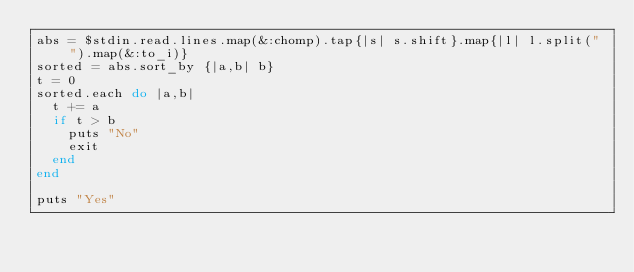<code> <loc_0><loc_0><loc_500><loc_500><_Ruby_>abs = $stdin.read.lines.map(&:chomp).tap{|s| s.shift}.map{|l| l.split(" ").map(&:to_i)}
sorted = abs.sort_by {|a,b| b}
t = 0
sorted.each do |a,b|
  t += a
  if t > b
    puts "No"
    exit
  end
end

puts "Yes"
</code> 